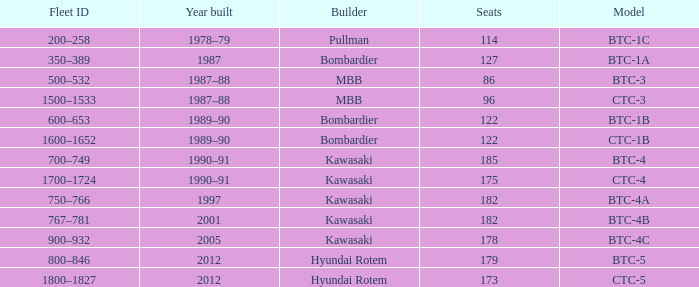What is the seating capacity of the btc-5 model? 179.0. 